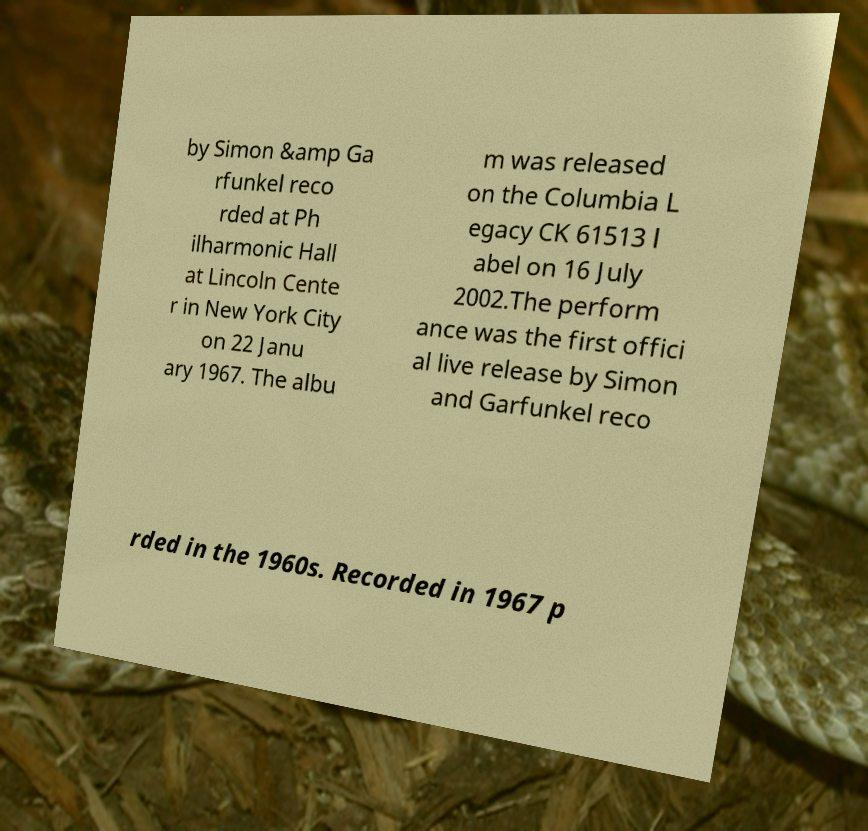Can you accurately transcribe the text from the provided image for me? by Simon &amp Ga rfunkel reco rded at Ph ilharmonic Hall at Lincoln Cente r in New York City on 22 Janu ary 1967. The albu m was released on the Columbia L egacy CK 61513 l abel on 16 July 2002.The perform ance was the first offici al live release by Simon and Garfunkel reco rded in the 1960s. Recorded in 1967 p 